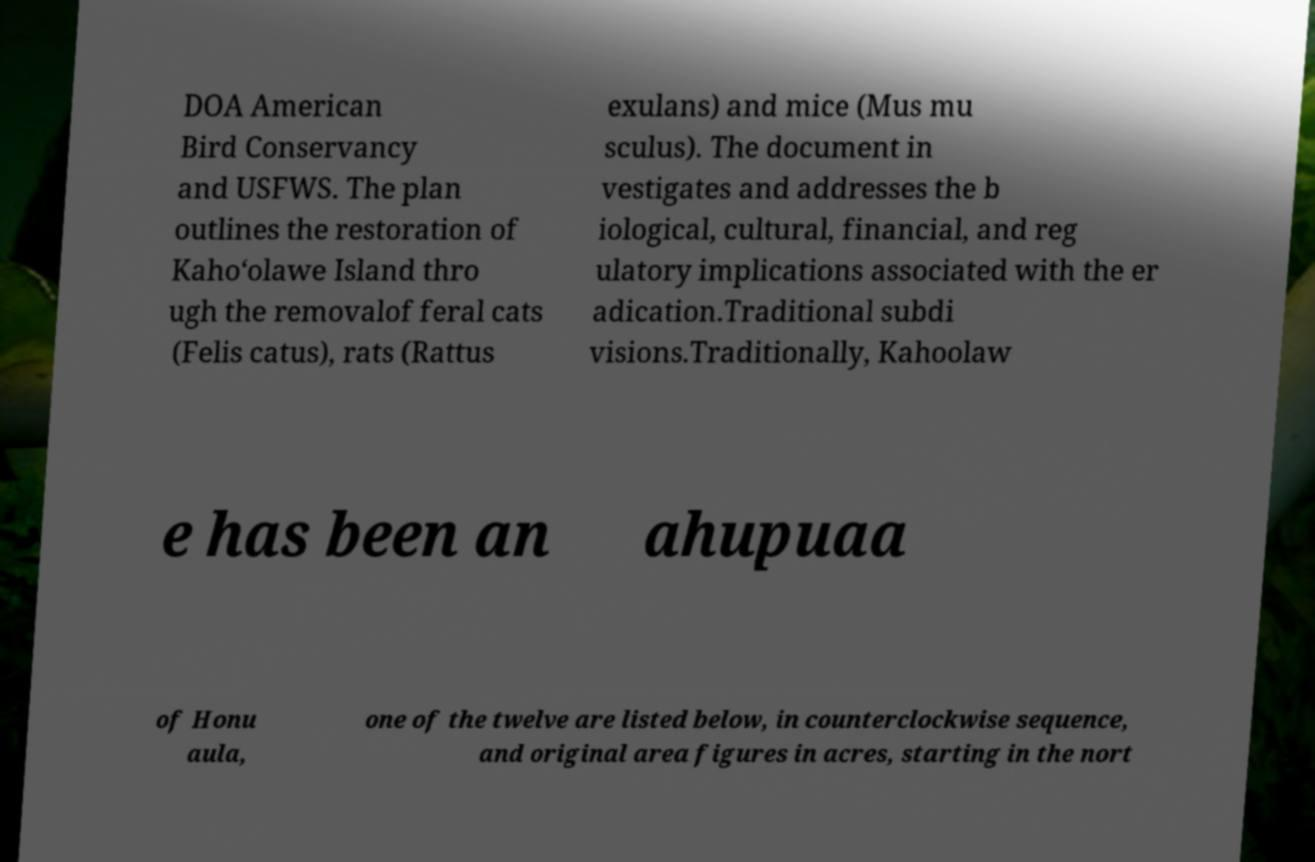There's text embedded in this image that I need extracted. Can you transcribe it verbatim? DOA American Bird Conservancy and USFWS. The plan outlines the restoration of Kaho‘olawe Island thro ugh the removalof feral cats (Felis catus), rats (Rattus exulans) and mice (Mus mu sculus). The document in vestigates and addresses the b iological, cultural, financial, and reg ulatory implications associated with the er adication.Traditional subdi visions.Traditionally, Kahoolaw e has been an ahupuaa of Honu aula, one of the twelve are listed below, in counterclockwise sequence, and original area figures in acres, starting in the nort 